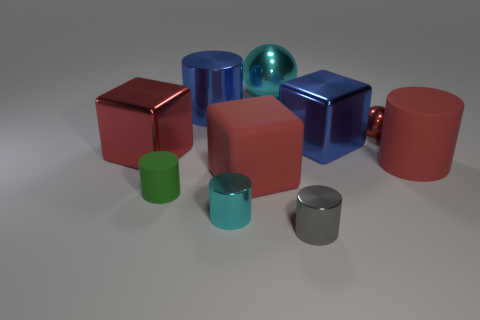What is the material of the red cylinder that is behind the cube in front of the large red block behind the big red cylinder?
Offer a very short reply. Rubber. What size is the red cube that is made of the same material as the large cyan thing?
Provide a short and direct response. Large. Is there anything else that is the same color as the tiny matte cylinder?
Provide a short and direct response. No. There is a large matte object to the left of the red cylinder; is its color the same as the small metal object behind the red cylinder?
Your response must be concise. Yes. What color is the cube that is left of the green cylinder?
Give a very brief answer. Red. There is a matte cylinder to the left of the gray cylinder; is its size the same as the small cyan thing?
Provide a succinct answer. Yes. Are there fewer red metallic spheres than metallic blocks?
Make the answer very short. Yes. What is the shape of the large shiny thing that is the same color as the tiny sphere?
Make the answer very short. Cube. There is a blue cylinder; how many small gray metal objects are left of it?
Your answer should be very brief. 0. Does the large cyan metal object have the same shape as the small red object?
Offer a very short reply. Yes. 